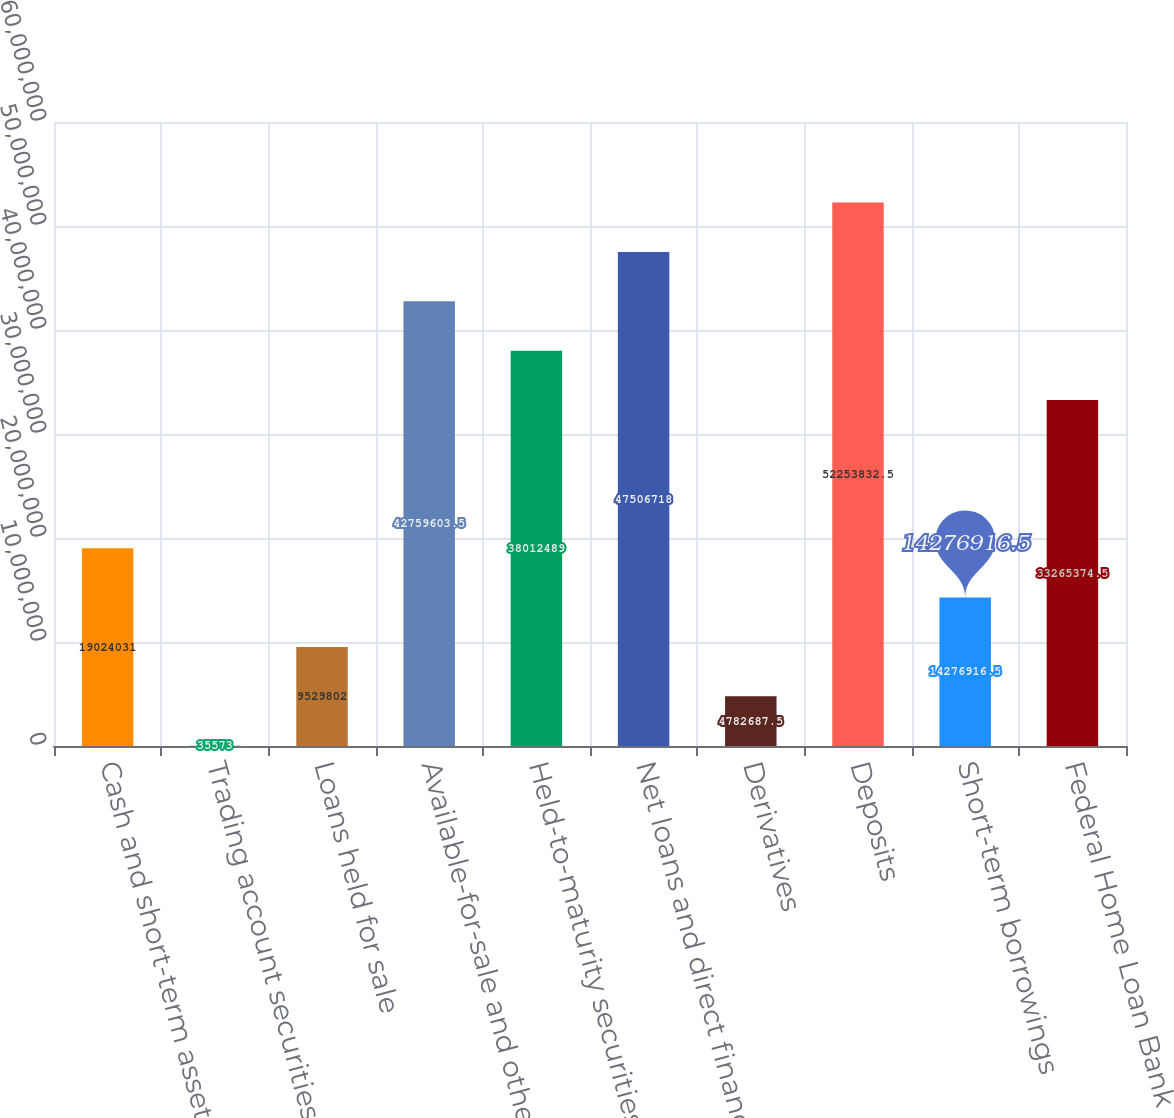Convert chart. <chart><loc_0><loc_0><loc_500><loc_500><bar_chart><fcel>Cash and short-term assets<fcel>Trading account securities<fcel>Loans held for sale<fcel>Available-for-sale and other<fcel>Held-to-maturity securities<fcel>Net loans and direct financing<fcel>Derivatives<fcel>Deposits<fcel>Short-term borrowings<fcel>Federal Home Loan Bank<nl><fcel>1.9024e+07<fcel>35573<fcel>9.5298e+06<fcel>4.27596e+07<fcel>3.80125e+07<fcel>4.75067e+07<fcel>4.78269e+06<fcel>5.22538e+07<fcel>1.42769e+07<fcel>3.32654e+07<nl></chart> 